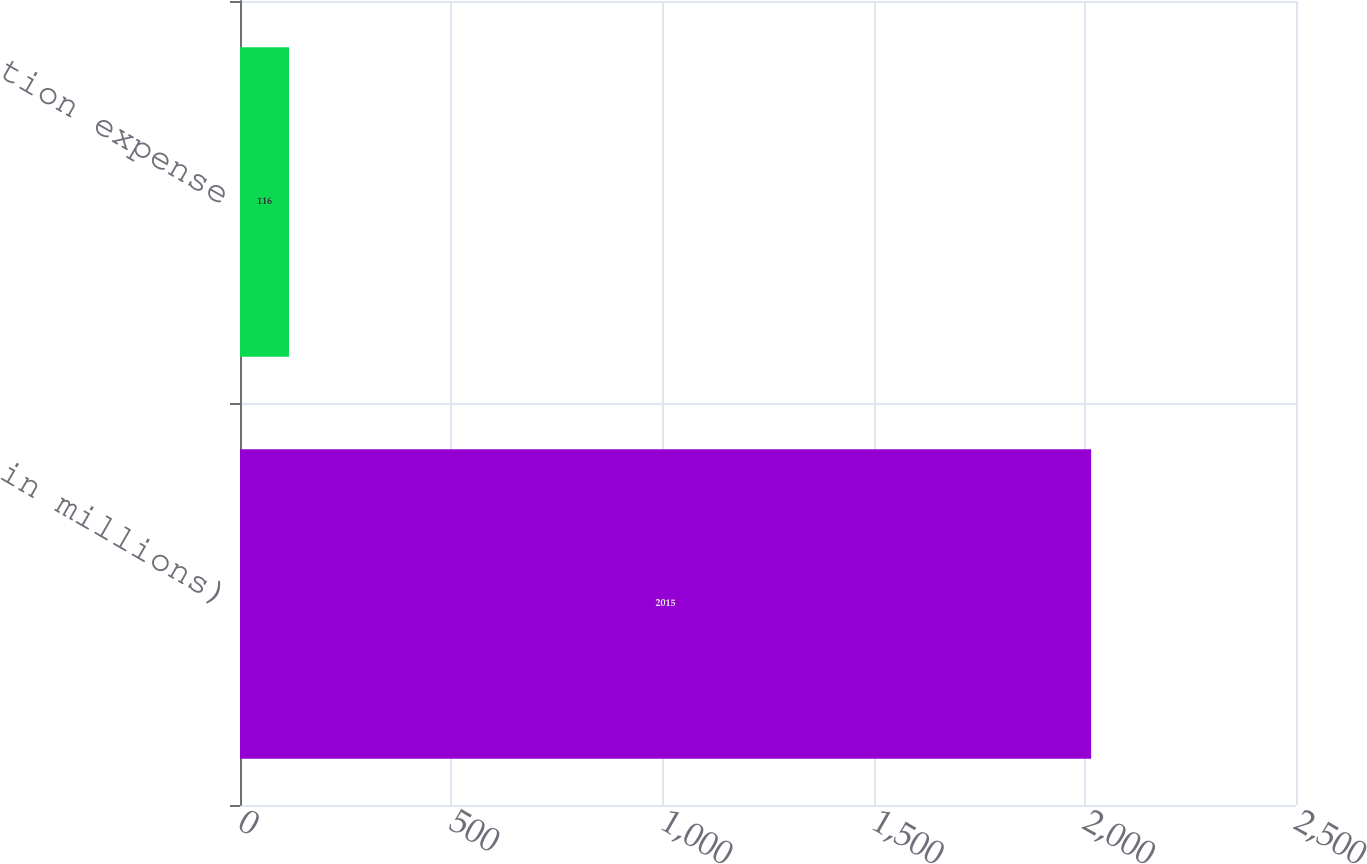Convert chart to OTSL. <chart><loc_0><loc_0><loc_500><loc_500><bar_chart><fcel>( in millions)<fcel>Amortization expense<nl><fcel>2015<fcel>116<nl></chart> 